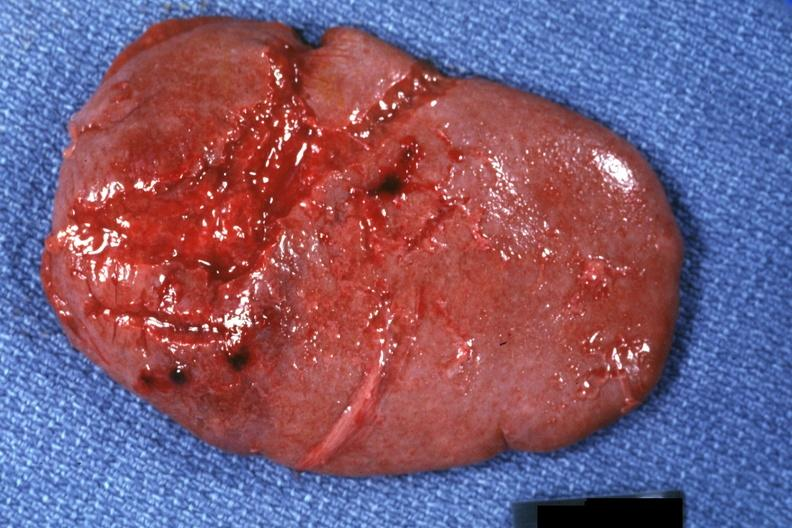s amputation stump infected present?
Answer the question using a single word or phrase. No 